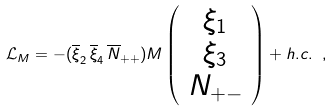Convert formula to latex. <formula><loc_0><loc_0><loc_500><loc_500>\mathcal { L } _ { M } = - ( \overline { \xi } _ { 2 } \, \overline { \xi } _ { 4 } \, \overline { N } _ { + + } ) M \left ( \begin{array} { c } { { \xi _ { 1 } } } \\ { { \xi _ { 3 } } } \\ { { N _ { + - } } } \end{array} \right ) + h . c . \ ,</formula> 